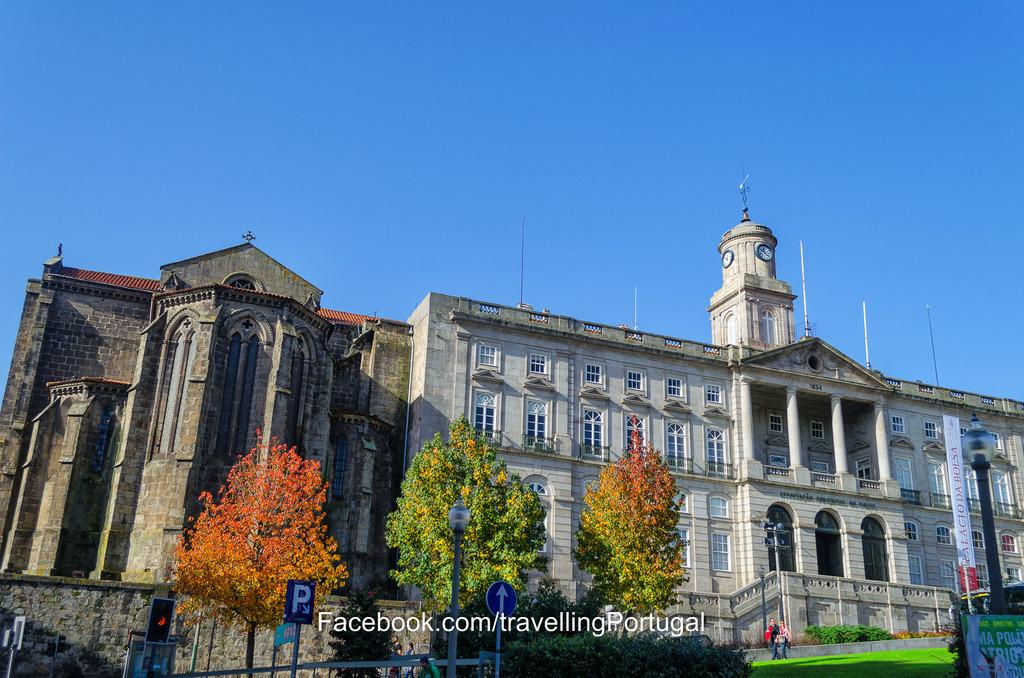Provide a one-sentence caption for the provided image. The beautiful Palaciode da Bolsa is in Portugal. 